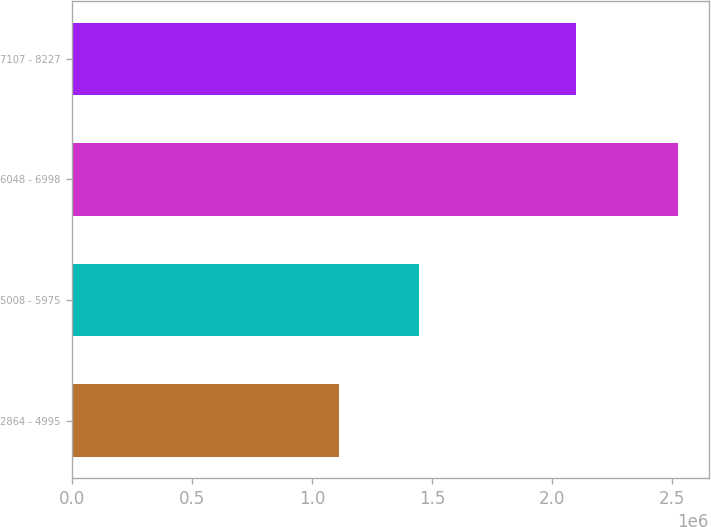Convert chart. <chart><loc_0><loc_0><loc_500><loc_500><bar_chart><fcel>2864 - 4995<fcel>5008 - 5975<fcel>6048 - 6998<fcel>7107 - 8227<nl><fcel>1.11391e+06<fcel>1.44406e+06<fcel>2.52521e+06<fcel>2.09852e+06<nl></chart> 